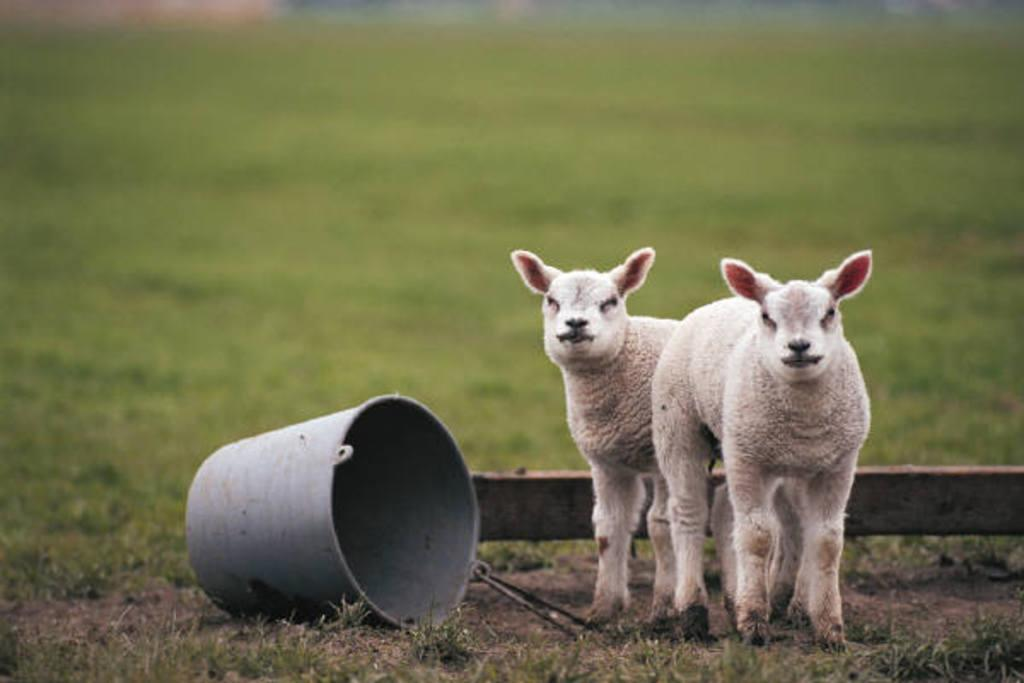What animals are present in the image? There are lambs in the image. What object can be seen near the lambs? There is a bucket in the image. What type of material is used to make the object near the lambs? The object near the lambs is made of wood. What is the condition of the background in the image? The background of the image is blurred. What type of vegetation is present on the ground in the image? There is grass on the ground in the image. What type of bubble can be seen floating near the lambs in the image? There is no bubble present in the image; it only features lambs, a bucket, a wooden piece, a blurred background, and grass on the ground. 